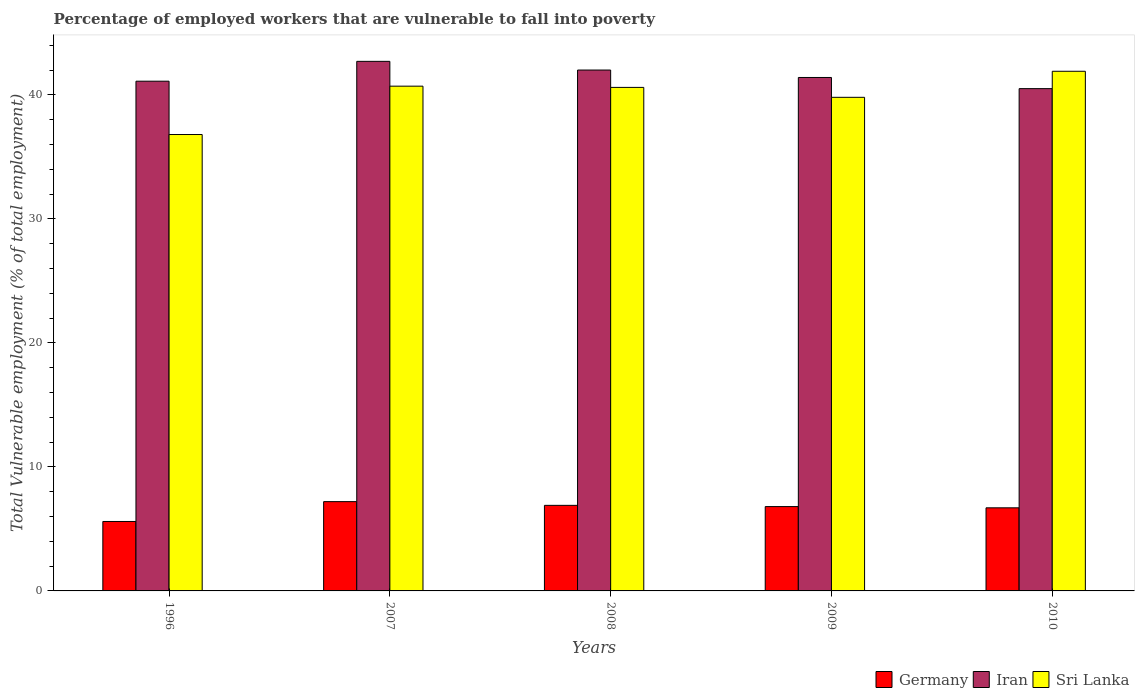How many different coloured bars are there?
Your answer should be compact. 3. How many groups of bars are there?
Keep it short and to the point. 5. Are the number of bars per tick equal to the number of legend labels?
Give a very brief answer. Yes. How many bars are there on the 1st tick from the left?
Your response must be concise. 3. What is the label of the 4th group of bars from the left?
Your answer should be very brief. 2009. What is the percentage of employed workers who are vulnerable to fall into poverty in Germany in 1996?
Give a very brief answer. 5.6. Across all years, what is the maximum percentage of employed workers who are vulnerable to fall into poverty in Iran?
Make the answer very short. 42.7. Across all years, what is the minimum percentage of employed workers who are vulnerable to fall into poverty in Germany?
Offer a terse response. 5.6. In which year was the percentage of employed workers who are vulnerable to fall into poverty in Germany maximum?
Make the answer very short. 2007. What is the total percentage of employed workers who are vulnerable to fall into poverty in Sri Lanka in the graph?
Your response must be concise. 199.8. What is the difference between the percentage of employed workers who are vulnerable to fall into poverty in Iran in 2007 and that in 2009?
Provide a succinct answer. 1.3. What is the difference between the percentage of employed workers who are vulnerable to fall into poverty in Iran in 2008 and the percentage of employed workers who are vulnerable to fall into poverty in Sri Lanka in 1996?
Offer a terse response. 5.2. What is the average percentage of employed workers who are vulnerable to fall into poverty in Iran per year?
Ensure brevity in your answer.  41.54. In the year 2009, what is the difference between the percentage of employed workers who are vulnerable to fall into poverty in Iran and percentage of employed workers who are vulnerable to fall into poverty in Germany?
Keep it short and to the point. 34.6. What is the ratio of the percentage of employed workers who are vulnerable to fall into poverty in Germany in 1996 to that in 2007?
Offer a very short reply. 0.78. Is the percentage of employed workers who are vulnerable to fall into poverty in Iran in 2008 less than that in 2009?
Make the answer very short. No. What is the difference between the highest and the second highest percentage of employed workers who are vulnerable to fall into poverty in Germany?
Make the answer very short. 0.3. What is the difference between the highest and the lowest percentage of employed workers who are vulnerable to fall into poverty in Sri Lanka?
Offer a very short reply. 5.1. What does the 2nd bar from the left in 2008 represents?
Your answer should be compact. Iran. What does the 2nd bar from the right in 2009 represents?
Ensure brevity in your answer.  Iran. Is it the case that in every year, the sum of the percentage of employed workers who are vulnerable to fall into poverty in Iran and percentage of employed workers who are vulnerable to fall into poverty in Germany is greater than the percentage of employed workers who are vulnerable to fall into poverty in Sri Lanka?
Your answer should be compact. Yes. How many bars are there?
Your response must be concise. 15. Are all the bars in the graph horizontal?
Your answer should be compact. No. What is the difference between two consecutive major ticks on the Y-axis?
Your response must be concise. 10. Are the values on the major ticks of Y-axis written in scientific E-notation?
Your answer should be compact. No. Does the graph contain any zero values?
Make the answer very short. No. Does the graph contain grids?
Provide a short and direct response. No. Where does the legend appear in the graph?
Your answer should be very brief. Bottom right. How many legend labels are there?
Offer a very short reply. 3. What is the title of the graph?
Your answer should be very brief. Percentage of employed workers that are vulnerable to fall into poverty. What is the label or title of the X-axis?
Your answer should be compact. Years. What is the label or title of the Y-axis?
Provide a succinct answer. Total Vulnerable employment (% of total employment). What is the Total Vulnerable employment (% of total employment) in Germany in 1996?
Offer a very short reply. 5.6. What is the Total Vulnerable employment (% of total employment) of Iran in 1996?
Keep it short and to the point. 41.1. What is the Total Vulnerable employment (% of total employment) in Sri Lanka in 1996?
Your response must be concise. 36.8. What is the Total Vulnerable employment (% of total employment) in Germany in 2007?
Provide a short and direct response. 7.2. What is the Total Vulnerable employment (% of total employment) in Iran in 2007?
Provide a short and direct response. 42.7. What is the Total Vulnerable employment (% of total employment) of Sri Lanka in 2007?
Give a very brief answer. 40.7. What is the Total Vulnerable employment (% of total employment) of Germany in 2008?
Offer a very short reply. 6.9. What is the Total Vulnerable employment (% of total employment) in Iran in 2008?
Your answer should be very brief. 42. What is the Total Vulnerable employment (% of total employment) in Sri Lanka in 2008?
Your answer should be compact. 40.6. What is the Total Vulnerable employment (% of total employment) of Germany in 2009?
Provide a succinct answer. 6.8. What is the Total Vulnerable employment (% of total employment) of Iran in 2009?
Provide a succinct answer. 41.4. What is the Total Vulnerable employment (% of total employment) in Sri Lanka in 2009?
Your answer should be very brief. 39.8. What is the Total Vulnerable employment (% of total employment) of Germany in 2010?
Provide a short and direct response. 6.7. What is the Total Vulnerable employment (% of total employment) in Iran in 2010?
Ensure brevity in your answer.  40.5. What is the Total Vulnerable employment (% of total employment) of Sri Lanka in 2010?
Make the answer very short. 41.9. Across all years, what is the maximum Total Vulnerable employment (% of total employment) in Germany?
Your answer should be very brief. 7.2. Across all years, what is the maximum Total Vulnerable employment (% of total employment) in Iran?
Provide a short and direct response. 42.7. Across all years, what is the maximum Total Vulnerable employment (% of total employment) of Sri Lanka?
Your answer should be very brief. 41.9. Across all years, what is the minimum Total Vulnerable employment (% of total employment) of Germany?
Your answer should be compact. 5.6. Across all years, what is the minimum Total Vulnerable employment (% of total employment) in Iran?
Make the answer very short. 40.5. Across all years, what is the minimum Total Vulnerable employment (% of total employment) of Sri Lanka?
Your answer should be very brief. 36.8. What is the total Total Vulnerable employment (% of total employment) in Germany in the graph?
Your answer should be very brief. 33.2. What is the total Total Vulnerable employment (% of total employment) in Iran in the graph?
Provide a short and direct response. 207.7. What is the total Total Vulnerable employment (% of total employment) of Sri Lanka in the graph?
Offer a terse response. 199.8. What is the difference between the Total Vulnerable employment (% of total employment) of Iran in 1996 and that in 2007?
Give a very brief answer. -1.6. What is the difference between the Total Vulnerable employment (% of total employment) in Iran in 1996 and that in 2008?
Make the answer very short. -0.9. What is the difference between the Total Vulnerable employment (% of total employment) of Germany in 1996 and that in 2009?
Ensure brevity in your answer.  -1.2. What is the difference between the Total Vulnerable employment (% of total employment) in Germany in 1996 and that in 2010?
Provide a succinct answer. -1.1. What is the difference between the Total Vulnerable employment (% of total employment) in Iran in 1996 and that in 2010?
Give a very brief answer. 0.6. What is the difference between the Total Vulnerable employment (% of total employment) in Sri Lanka in 2007 and that in 2009?
Provide a succinct answer. 0.9. What is the difference between the Total Vulnerable employment (% of total employment) of Iran in 2007 and that in 2010?
Your response must be concise. 2.2. What is the difference between the Total Vulnerable employment (% of total employment) of Sri Lanka in 2007 and that in 2010?
Offer a very short reply. -1.2. What is the difference between the Total Vulnerable employment (% of total employment) in Germany in 2008 and that in 2009?
Your answer should be compact. 0.1. What is the difference between the Total Vulnerable employment (% of total employment) of Iran in 2008 and that in 2009?
Your answer should be very brief. 0.6. What is the difference between the Total Vulnerable employment (% of total employment) in Iran in 2009 and that in 2010?
Your answer should be compact. 0.9. What is the difference between the Total Vulnerable employment (% of total employment) of Germany in 1996 and the Total Vulnerable employment (% of total employment) of Iran in 2007?
Your answer should be compact. -37.1. What is the difference between the Total Vulnerable employment (% of total employment) of Germany in 1996 and the Total Vulnerable employment (% of total employment) of Sri Lanka in 2007?
Your answer should be compact. -35.1. What is the difference between the Total Vulnerable employment (% of total employment) in Germany in 1996 and the Total Vulnerable employment (% of total employment) in Iran in 2008?
Keep it short and to the point. -36.4. What is the difference between the Total Vulnerable employment (% of total employment) in Germany in 1996 and the Total Vulnerable employment (% of total employment) in Sri Lanka in 2008?
Ensure brevity in your answer.  -35. What is the difference between the Total Vulnerable employment (% of total employment) in Germany in 1996 and the Total Vulnerable employment (% of total employment) in Iran in 2009?
Offer a terse response. -35.8. What is the difference between the Total Vulnerable employment (% of total employment) in Germany in 1996 and the Total Vulnerable employment (% of total employment) in Sri Lanka in 2009?
Offer a terse response. -34.2. What is the difference between the Total Vulnerable employment (% of total employment) of Iran in 1996 and the Total Vulnerable employment (% of total employment) of Sri Lanka in 2009?
Make the answer very short. 1.3. What is the difference between the Total Vulnerable employment (% of total employment) of Germany in 1996 and the Total Vulnerable employment (% of total employment) of Iran in 2010?
Your answer should be very brief. -34.9. What is the difference between the Total Vulnerable employment (% of total employment) of Germany in 1996 and the Total Vulnerable employment (% of total employment) of Sri Lanka in 2010?
Your answer should be very brief. -36.3. What is the difference between the Total Vulnerable employment (% of total employment) in Iran in 1996 and the Total Vulnerable employment (% of total employment) in Sri Lanka in 2010?
Offer a terse response. -0.8. What is the difference between the Total Vulnerable employment (% of total employment) in Germany in 2007 and the Total Vulnerable employment (% of total employment) in Iran in 2008?
Your answer should be very brief. -34.8. What is the difference between the Total Vulnerable employment (% of total employment) of Germany in 2007 and the Total Vulnerable employment (% of total employment) of Sri Lanka in 2008?
Keep it short and to the point. -33.4. What is the difference between the Total Vulnerable employment (% of total employment) in Iran in 2007 and the Total Vulnerable employment (% of total employment) in Sri Lanka in 2008?
Your response must be concise. 2.1. What is the difference between the Total Vulnerable employment (% of total employment) in Germany in 2007 and the Total Vulnerable employment (% of total employment) in Iran in 2009?
Offer a very short reply. -34.2. What is the difference between the Total Vulnerable employment (% of total employment) in Germany in 2007 and the Total Vulnerable employment (% of total employment) in Sri Lanka in 2009?
Your response must be concise. -32.6. What is the difference between the Total Vulnerable employment (% of total employment) of Iran in 2007 and the Total Vulnerable employment (% of total employment) of Sri Lanka in 2009?
Make the answer very short. 2.9. What is the difference between the Total Vulnerable employment (% of total employment) of Germany in 2007 and the Total Vulnerable employment (% of total employment) of Iran in 2010?
Provide a succinct answer. -33.3. What is the difference between the Total Vulnerable employment (% of total employment) of Germany in 2007 and the Total Vulnerable employment (% of total employment) of Sri Lanka in 2010?
Offer a very short reply. -34.7. What is the difference between the Total Vulnerable employment (% of total employment) of Iran in 2007 and the Total Vulnerable employment (% of total employment) of Sri Lanka in 2010?
Your response must be concise. 0.8. What is the difference between the Total Vulnerable employment (% of total employment) in Germany in 2008 and the Total Vulnerable employment (% of total employment) in Iran in 2009?
Your answer should be very brief. -34.5. What is the difference between the Total Vulnerable employment (% of total employment) of Germany in 2008 and the Total Vulnerable employment (% of total employment) of Sri Lanka in 2009?
Make the answer very short. -32.9. What is the difference between the Total Vulnerable employment (% of total employment) in Iran in 2008 and the Total Vulnerable employment (% of total employment) in Sri Lanka in 2009?
Ensure brevity in your answer.  2.2. What is the difference between the Total Vulnerable employment (% of total employment) of Germany in 2008 and the Total Vulnerable employment (% of total employment) of Iran in 2010?
Offer a very short reply. -33.6. What is the difference between the Total Vulnerable employment (% of total employment) in Germany in 2008 and the Total Vulnerable employment (% of total employment) in Sri Lanka in 2010?
Your answer should be very brief. -35. What is the difference between the Total Vulnerable employment (% of total employment) in Germany in 2009 and the Total Vulnerable employment (% of total employment) in Iran in 2010?
Give a very brief answer. -33.7. What is the difference between the Total Vulnerable employment (% of total employment) in Germany in 2009 and the Total Vulnerable employment (% of total employment) in Sri Lanka in 2010?
Your answer should be compact. -35.1. What is the average Total Vulnerable employment (% of total employment) in Germany per year?
Make the answer very short. 6.64. What is the average Total Vulnerable employment (% of total employment) in Iran per year?
Provide a succinct answer. 41.54. What is the average Total Vulnerable employment (% of total employment) in Sri Lanka per year?
Provide a short and direct response. 39.96. In the year 1996, what is the difference between the Total Vulnerable employment (% of total employment) in Germany and Total Vulnerable employment (% of total employment) in Iran?
Your answer should be compact. -35.5. In the year 1996, what is the difference between the Total Vulnerable employment (% of total employment) of Germany and Total Vulnerable employment (% of total employment) of Sri Lanka?
Provide a short and direct response. -31.2. In the year 1996, what is the difference between the Total Vulnerable employment (% of total employment) in Iran and Total Vulnerable employment (% of total employment) in Sri Lanka?
Your response must be concise. 4.3. In the year 2007, what is the difference between the Total Vulnerable employment (% of total employment) in Germany and Total Vulnerable employment (% of total employment) in Iran?
Make the answer very short. -35.5. In the year 2007, what is the difference between the Total Vulnerable employment (% of total employment) of Germany and Total Vulnerable employment (% of total employment) of Sri Lanka?
Offer a terse response. -33.5. In the year 2007, what is the difference between the Total Vulnerable employment (% of total employment) of Iran and Total Vulnerable employment (% of total employment) of Sri Lanka?
Offer a terse response. 2. In the year 2008, what is the difference between the Total Vulnerable employment (% of total employment) in Germany and Total Vulnerable employment (% of total employment) in Iran?
Make the answer very short. -35.1. In the year 2008, what is the difference between the Total Vulnerable employment (% of total employment) of Germany and Total Vulnerable employment (% of total employment) of Sri Lanka?
Offer a terse response. -33.7. In the year 2008, what is the difference between the Total Vulnerable employment (% of total employment) in Iran and Total Vulnerable employment (% of total employment) in Sri Lanka?
Your response must be concise. 1.4. In the year 2009, what is the difference between the Total Vulnerable employment (% of total employment) of Germany and Total Vulnerable employment (% of total employment) of Iran?
Keep it short and to the point. -34.6. In the year 2009, what is the difference between the Total Vulnerable employment (% of total employment) in Germany and Total Vulnerable employment (% of total employment) in Sri Lanka?
Provide a short and direct response. -33. In the year 2010, what is the difference between the Total Vulnerable employment (% of total employment) in Germany and Total Vulnerable employment (% of total employment) in Iran?
Keep it short and to the point. -33.8. In the year 2010, what is the difference between the Total Vulnerable employment (% of total employment) of Germany and Total Vulnerable employment (% of total employment) of Sri Lanka?
Your answer should be very brief. -35.2. What is the ratio of the Total Vulnerable employment (% of total employment) in Germany in 1996 to that in 2007?
Offer a terse response. 0.78. What is the ratio of the Total Vulnerable employment (% of total employment) in Iran in 1996 to that in 2007?
Keep it short and to the point. 0.96. What is the ratio of the Total Vulnerable employment (% of total employment) of Sri Lanka in 1996 to that in 2007?
Offer a terse response. 0.9. What is the ratio of the Total Vulnerable employment (% of total employment) of Germany in 1996 to that in 2008?
Provide a short and direct response. 0.81. What is the ratio of the Total Vulnerable employment (% of total employment) in Iran in 1996 to that in 2008?
Keep it short and to the point. 0.98. What is the ratio of the Total Vulnerable employment (% of total employment) of Sri Lanka in 1996 to that in 2008?
Provide a short and direct response. 0.91. What is the ratio of the Total Vulnerable employment (% of total employment) in Germany in 1996 to that in 2009?
Ensure brevity in your answer.  0.82. What is the ratio of the Total Vulnerable employment (% of total employment) in Iran in 1996 to that in 2009?
Provide a short and direct response. 0.99. What is the ratio of the Total Vulnerable employment (% of total employment) of Sri Lanka in 1996 to that in 2009?
Give a very brief answer. 0.92. What is the ratio of the Total Vulnerable employment (% of total employment) of Germany in 1996 to that in 2010?
Give a very brief answer. 0.84. What is the ratio of the Total Vulnerable employment (% of total employment) of Iran in 1996 to that in 2010?
Your response must be concise. 1.01. What is the ratio of the Total Vulnerable employment (% of total employment) in Sri Lanka in 1996 to that in 2010?
Your answer should be compact. 0.88. What is the ratio of the Total Vulnerable employment (% of total employment) in Germany in 2007 to that in 2008?
Make the answer very short. 1.04. What is the ratio of the Total Vulnerable employment (% of total employment) of Iran in 2007 to that in 2008?
Provide a succinct answer. 1.02. What is the ratio of the Total Vulnerable employment (% of total employment) in Germany in 2007 to that in 2009?
Keep it short and to the point. 1.06. What is the ratio of the Total Vulnerable employment (% of total employment) of Iran in 2007 to that in 2009?
Ensure brevity in your answer.  1.03. What is the ratio of the Total Vulnerable employment (% of total employment) of Sri Lanka in 2007 to that in 2009?
Give a very brief answer. 1.02. What is the ratio of the Total Vulnerable employment (% of total employment) in Germany in 2007 to that in 2010?
Provide a succinct answer. 1.07. What is the ratio of the Total Vulnerable employment (% of total employment) of Iran in 2007 to that in 2010?
Your answer should be compact. 1.05. What is the ratio of the Total Vulnerable employment (% of total employment) in Sri Lanka in 2007 to that in 2010?
Your answer should be compact. 0.97. What is the ratio of the Total Vulnerable employment (% of total employment) in Germany in 2008 to that in 2009?
Provide a short and direct response. 1.01. What is the ratio of the Total Vulnerable employment (% of total employment) of Iran in 2008 to that in 2009?
Make the answer very short. 1.01. What is the ratio of the Total Vulnerable employment (% of total employment) of Sri Lanka in 2008 to that in 2009?
Provide a short and direct response. 1.02. What is the ratio of the Total Vulnerable employment (% of total employment) of Germany in 2008 to that in 2010?
Your response must be concise. 1.03. What is the ratio of the Total Vulnerable employment (% of total employment) in Germany in 2009 to that in 2010?
Offer a terse response. 1.01. What is the ratio of the Total Vulnerable employment (% of total employment) of Iran in 2009 to that in 2010?
Your answer should be very brief. 1.02. What is the ratio of the Total Vulnerable employment (% of total employment) of Sri Lanka in 2009 to that in 2010?
Ensure brevity in your answer.  0.95. What is the difference between the highest and the second highest Total Vulnerable employment (% of total employment) of Iran?
Keep it short and to the point. 0.7. What is the difference between the highest and the second highest Total Vulnerable employment (% of total employment) of Sri Lanka?
Provide a short and direct response. 1.2. What is the difference between the highest and the lowest Total Vulnerable employment (% of total employment) in Iran?
Your response must be concise. 2.2. 